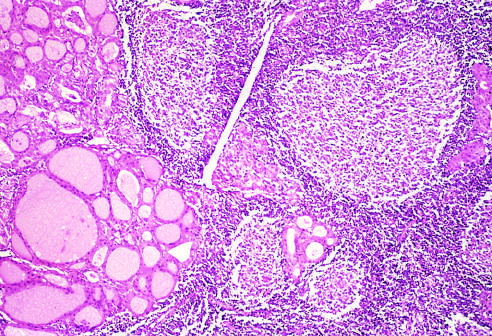what contains a dense lymphocytic infiltrate with germinal centers?
Answer the question using a single word or phrase. The thyroid parenchyma 